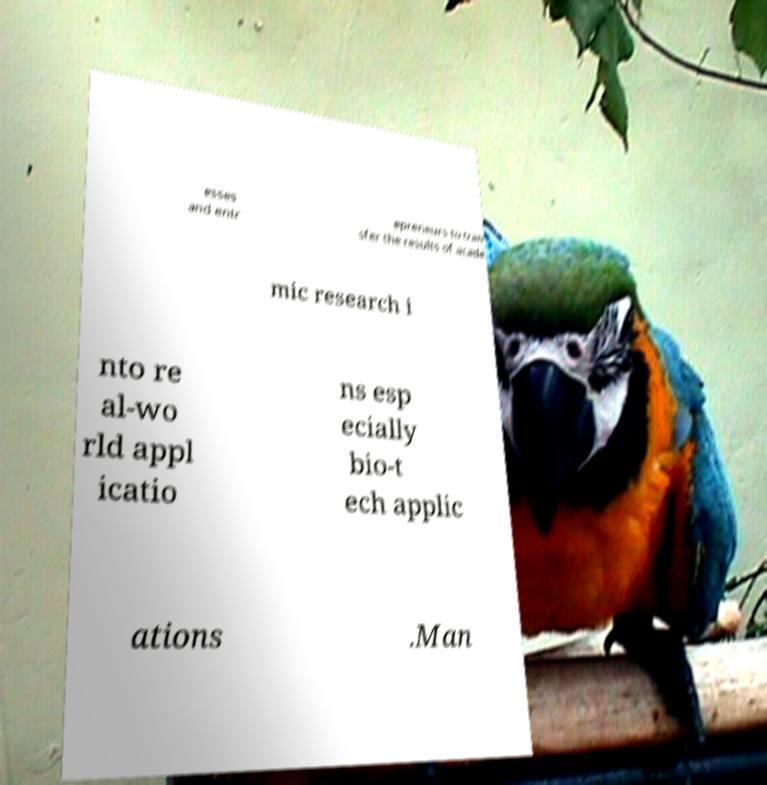Can you read and provide the text displayed in the image?This photo seems to have some interesting text. Can you extract and type it out for me? esses and entr epreneurs to tran sfer the results of acade mic research i nto re al-wo rld appl icatio ns esp ecially bio-t ech applic ations .Man 